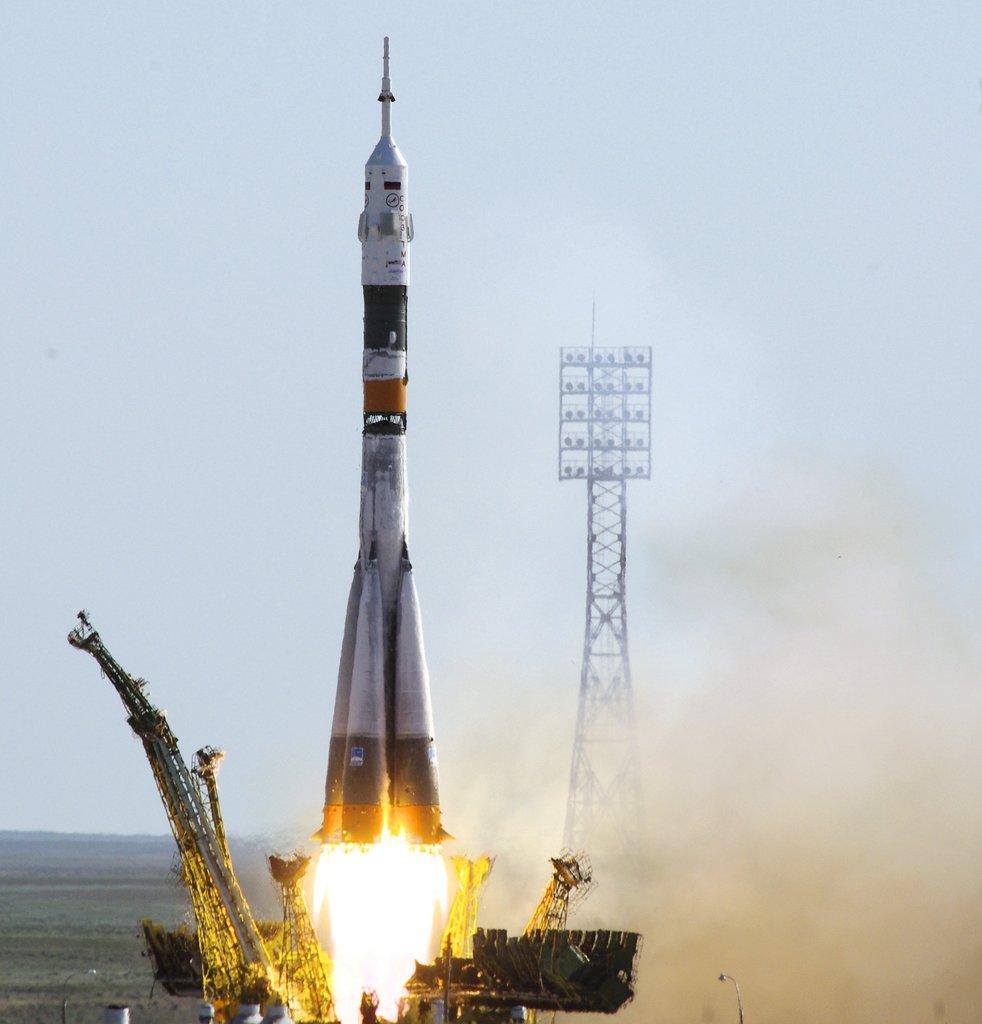How would you summarize this image in a sentence or two? In this image I can see a rocket is moving at the bottom there is the fire. On the right side there is an iron frame, at the top it is the sky. 